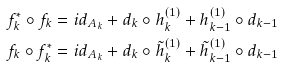Convert formula to latex. <formula><loc_0><loc_0><loc_500><loc_500>f ^ { * } _ { k } \circ f _ { k } & = i d _ { A _ { k } } + d _ { k } \circ h ^ { ( 1 ) } _ { k } + h ^ { ( 1 ) } _ { k - 1 } \circ d _ { k - 1 } \\ f _ { k } \circ f ^ { * } _ { k } & = i d _ { A _ { k } } + d _ { k } \circ \tilde { h } ^ { ( 1 ) } _ { k } + \tilde { h } ^ { ( 1 ) } _ { k - 1 } \circ d _ { k - 1 }</formula> 